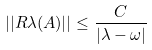Convert formula to latex. <formula><loc_0><loc_0><loc_500><loc_500>| | R \lambda ( A ) | | \leq \frac { C } { | \lambda - \omega | }</formula> 